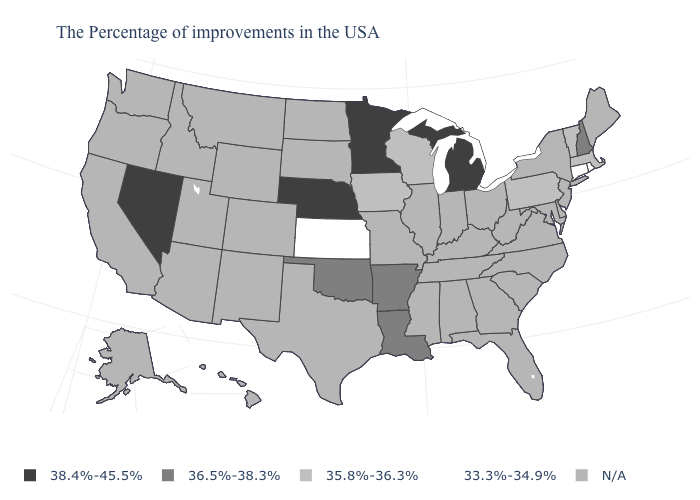Among the states that border New Hampshire , which have the lowest value?
Answer briefly. Massachusetts, Vermont. How many symbols are there in the legend?
Keep it brief. 5. What is the value of South Carolina?
Write a very short answer. N/A. Is the legend a continuous bar?
Keep it brief. No. What is the value of Michigan?
Quick response, please. 38.4%-45.5%. What is the value of Massachusetts?
Answer briefly. 35.8%-36.3%. Name the states that have a value in the range 33.3%-34.9%?
Short answer required. Rhode Island, Connecticut, Kansas. What is the lowest value in the USA?
Quick response, please. 33.3%-34.9%. What is the value of Nevada?
Quick response, please. 38.4%-45.5%. Name the states that have a value in the range 36.5%-38.3%?
Concise answer only. New Hampshire, Louisiana, Arkansas, Oklahoma. What is the lowest value in states that border Colorado?
Be succinct. 33.3%-34.9%. What is the value of New York?
Short answer required. N/A. What is the value of Kansas?
Give a very brief answer. 33.3%-34.9%. 